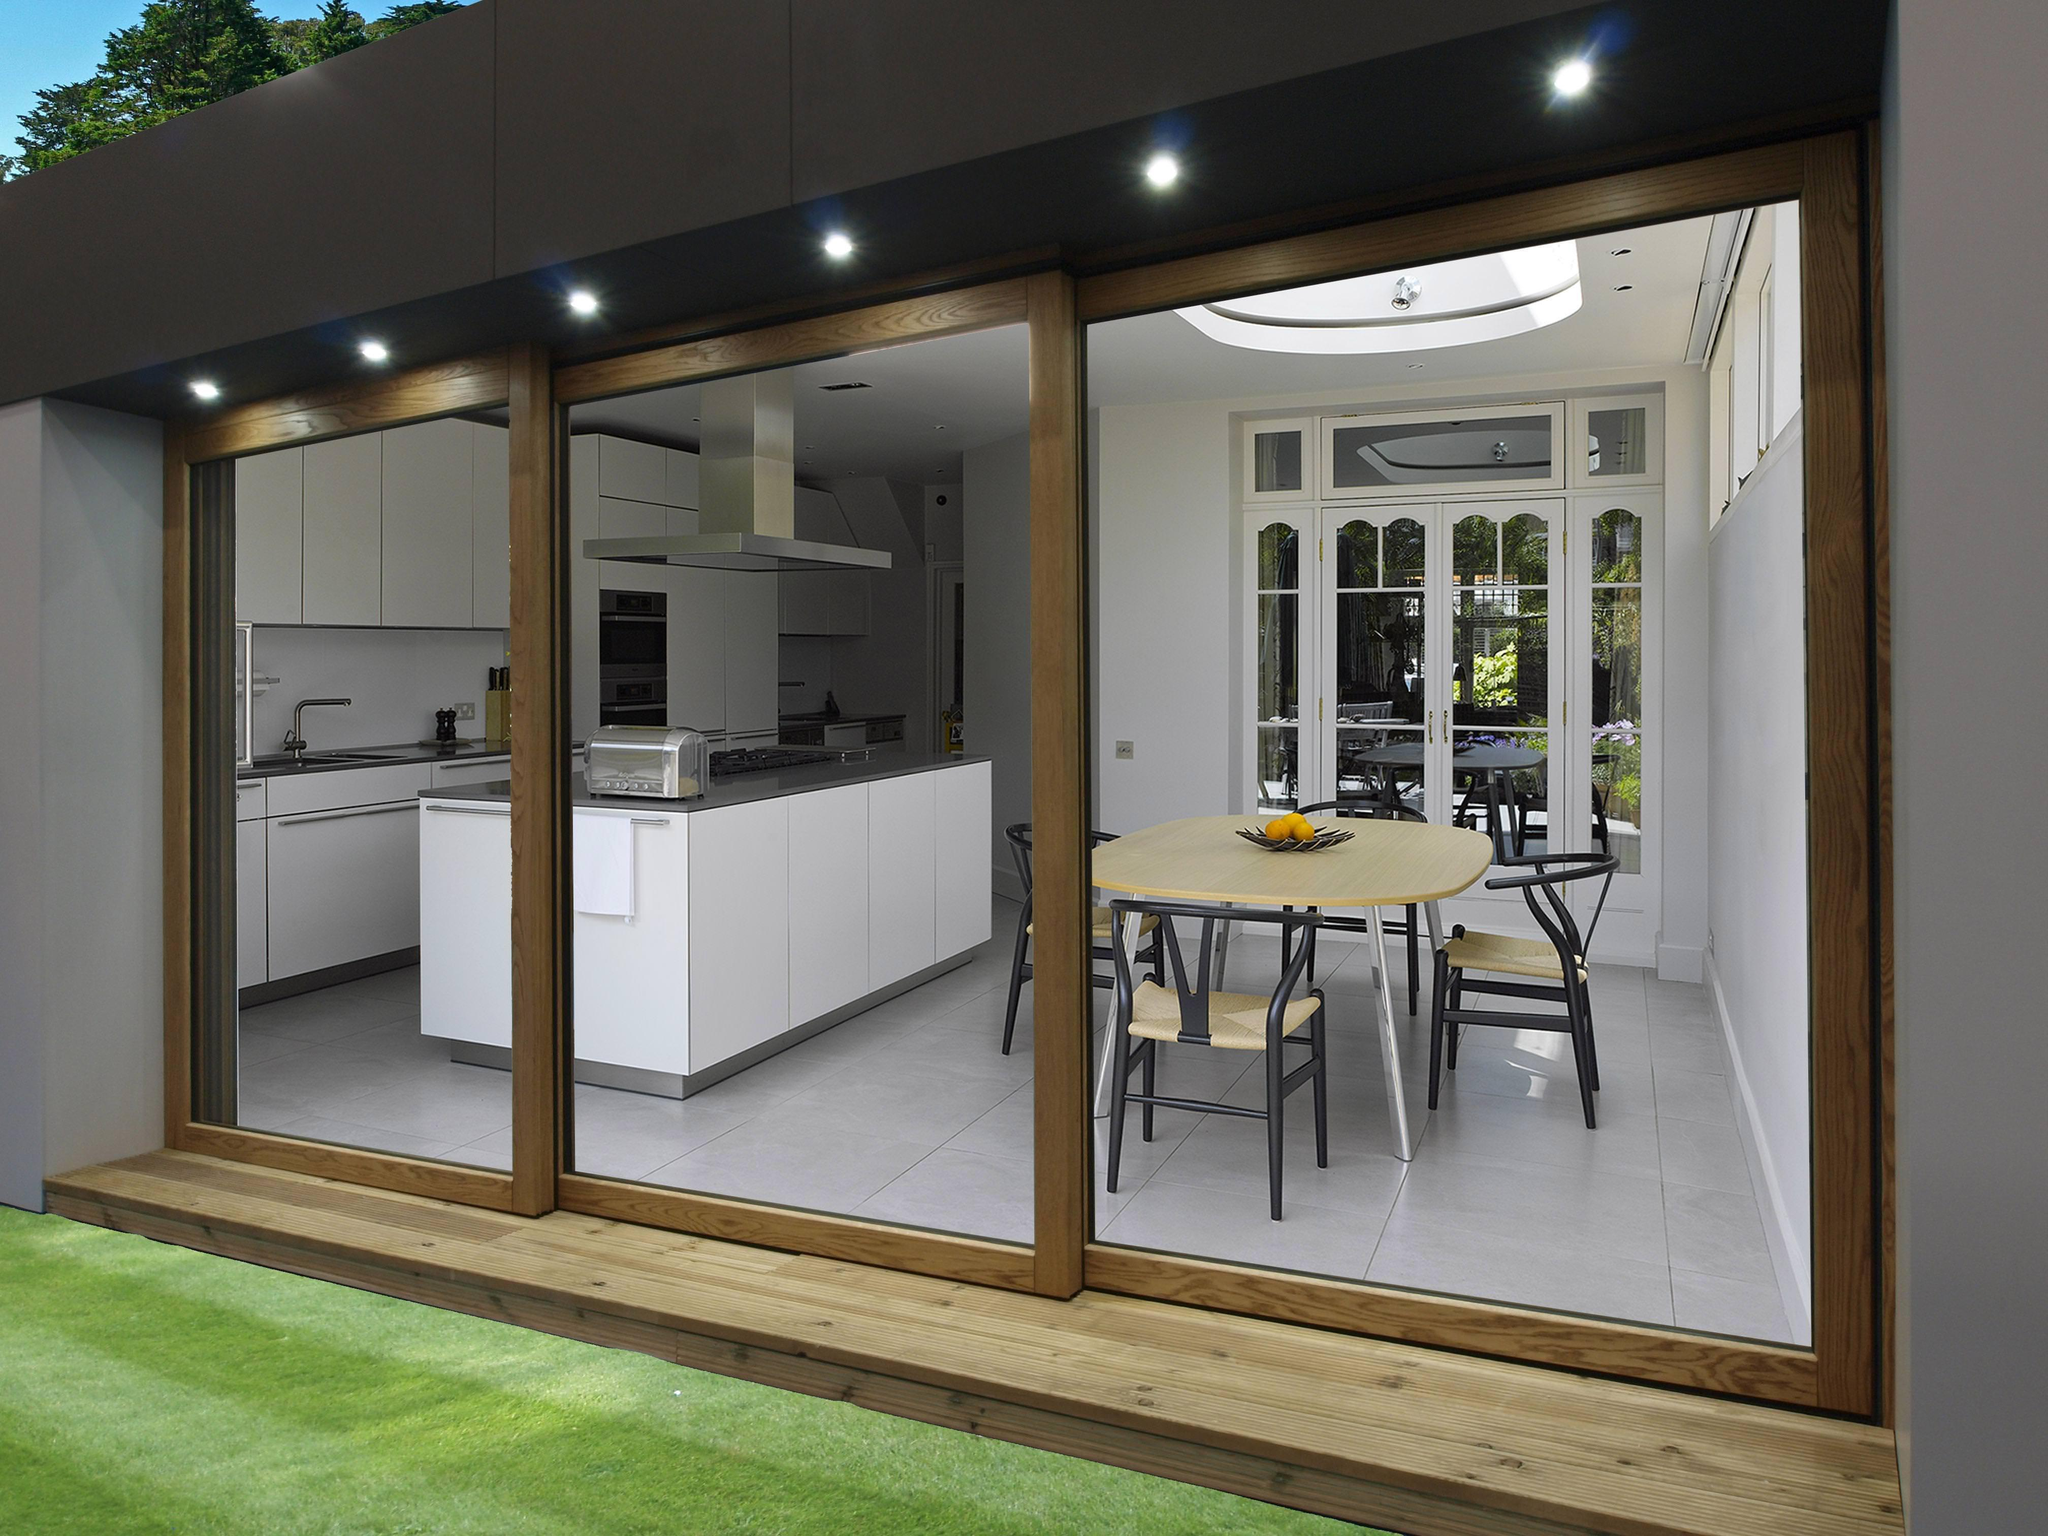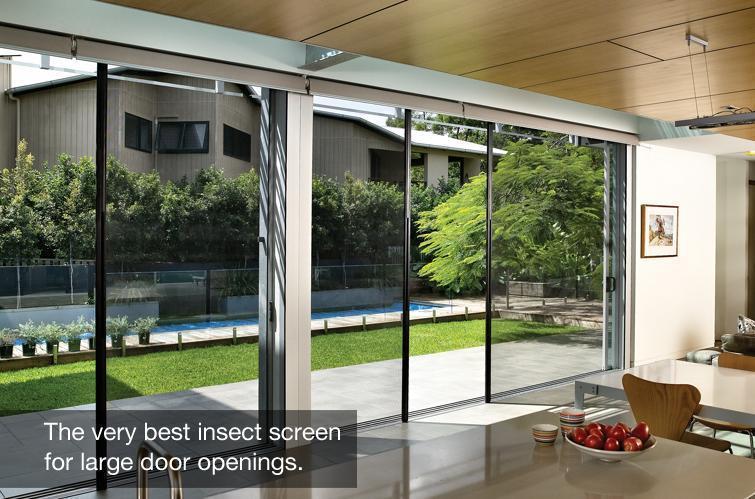The first image is the image on the left, the second image is the image on the right. Considering the images on both sides, is "There are two glass door with multiple panes that reveal grass and foliage in the backyard." valid? Answer yes or no. Yes. 